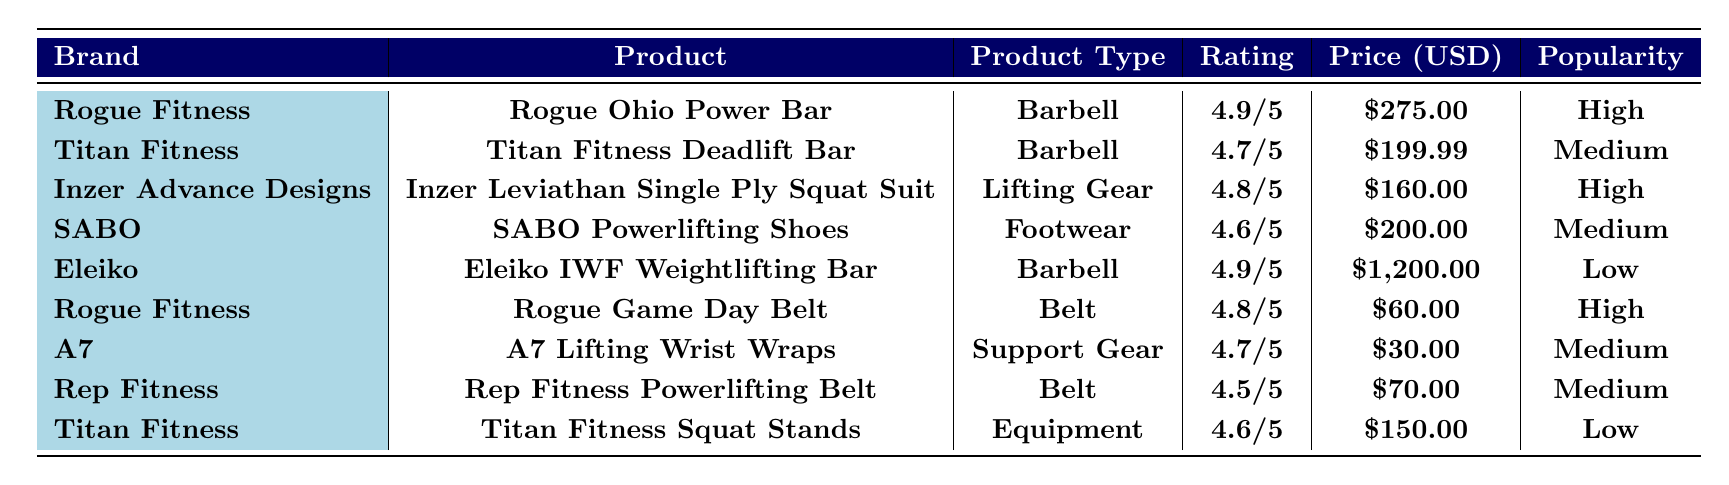What is the highest rated product in the table? The table lists products with their ratings, and the highest rating is **4.9/5**, which corresponds to both the **Rogue Ohio Power Bar** and the **Eleiko IWF Weightlifting Bar**.
Answer: Rogue Ohio Power Bar and Eleiko IWF Weightlifting Bar Which brand has the most popular product? By examining the popularity ratings, **Rogue Fitness** has two products listed as **High**, which are the **Rogue Ohio Power Bar** and the **Rogue Game Day Belt**.
Answer: Rogue Fitness What is the price difference between the cheapest and most expensive products? The cheapest product is the **A7 Lifting Wrist Wraps** at **$30.00** and the most expensive product is the **Eleiko IWF Weightlifting Bar** at **$1,200.00**. The price difference is **$1,200.00 - $30.00 = $1,170.00**.
Answer: $1,170.00 List all products with a rating greater than **4.7/5**. The products with a rating greater than **4.7/5** include the **Rogue Ohio Power Bar (4.9/5)**, **Eleiko IWF Weightlifting Bar (4.9/5)**, **Inzer Leviathan Single Ply Squat Suit (4.8/5)**, and **Rogue Game Day Belt (4.8/5)**.
Answer: Rogue Ohio Power Bar, Eleiko IWF Weightlifting Bar, Inzer Leviathan Single Ply Squat Suit, Rogue Game Day Belt Which product is more popular: the **Titan Fitness Deadlift Bar** or the **SABO Powerlifting Shoes**? The **Titan Fitness Deadlift Bar** has a **Medium** popularity rating, while the **SABO Powerlifting Shoes** also have a **Medium** popularity rating. Thus, they are equally popular.
Answer: They are equally popular How many products listed are from **Titan Fitness**? There are two products from **Titan Fitness** listed in the table: the **Titan Fitness Deadlift Bar** and the **Titan Fitness Squat Stands**.
Answer: 2 What is the average rating of all products from **Rogue Fitness**? The ratings for **Rogue Fitness** products are **4.9/5** (Rogue Ohio Power Bar) and **4.8/5** (Rogue Game Day Belt). To find the average, add them: **(4.9 + 4.8)/2 = 4.85**.
Answer: 4.85 Is the **Inzer Leviathan Single Ply Squat Suit** more expensive than the **Rep Fitness Powerlifting Belt**? The **Inzer Leviathan Single Ply Squat Suit** costs **$160.00**, while the **Rep Fitness Powerlifting Belt** costs **$70.00**. Since **$160.00 > $70.00**, it is more expensive.
Answer: Yes How many products have a price under **$100**? The products with a price under **$100** are the **Rogue Game Day Belt ($60.00)** and the **A7 Lifting Wrist Wraps ($30.00)**; there are **two** such products.
Answer: 2 What is the total cost of products with a **High** popularity rating? The products with a **High** popularity rating are the **Rogue Ohio Power Bar ($275.00)**, **Inzer Leviathan Single Ply Squat Suit ($160.00)**, and **Rogue Game Day Belt ($60.00)**. The total cost: **$275.00 + $160.00 + $60.00 = $495.00**.
Answer: $495.00 